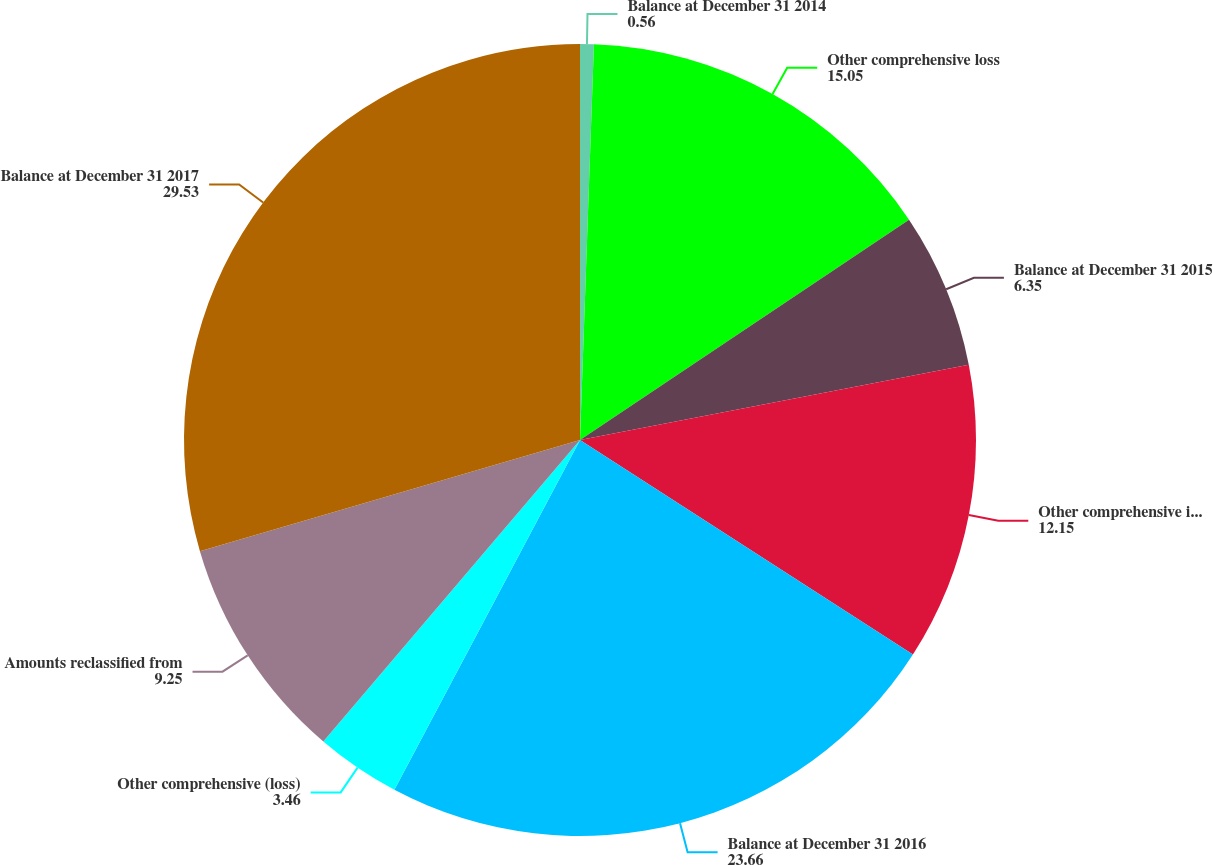<chart> <loc_0><loc_0><loc_500><loc_500><pie_chart><fcel>Balance at December 31 2014<fcel>Other comprehensive loss<fcel>Balance at December 31 2015<fcel>Other comprehensive income<fcel>Balance at December 31 2016<fcel>Other comprehensive (loss)<fcel>Amounts reclassified from<fcel>Balance at December 31 2017<nl><fcel>0.56%<fcel>15.05%<fcel>6.35%<fcel>12.15%<fcel>23.66%<fcel>3.46%<fcel>9.25%<fcel>29.53%<nl></chart> 